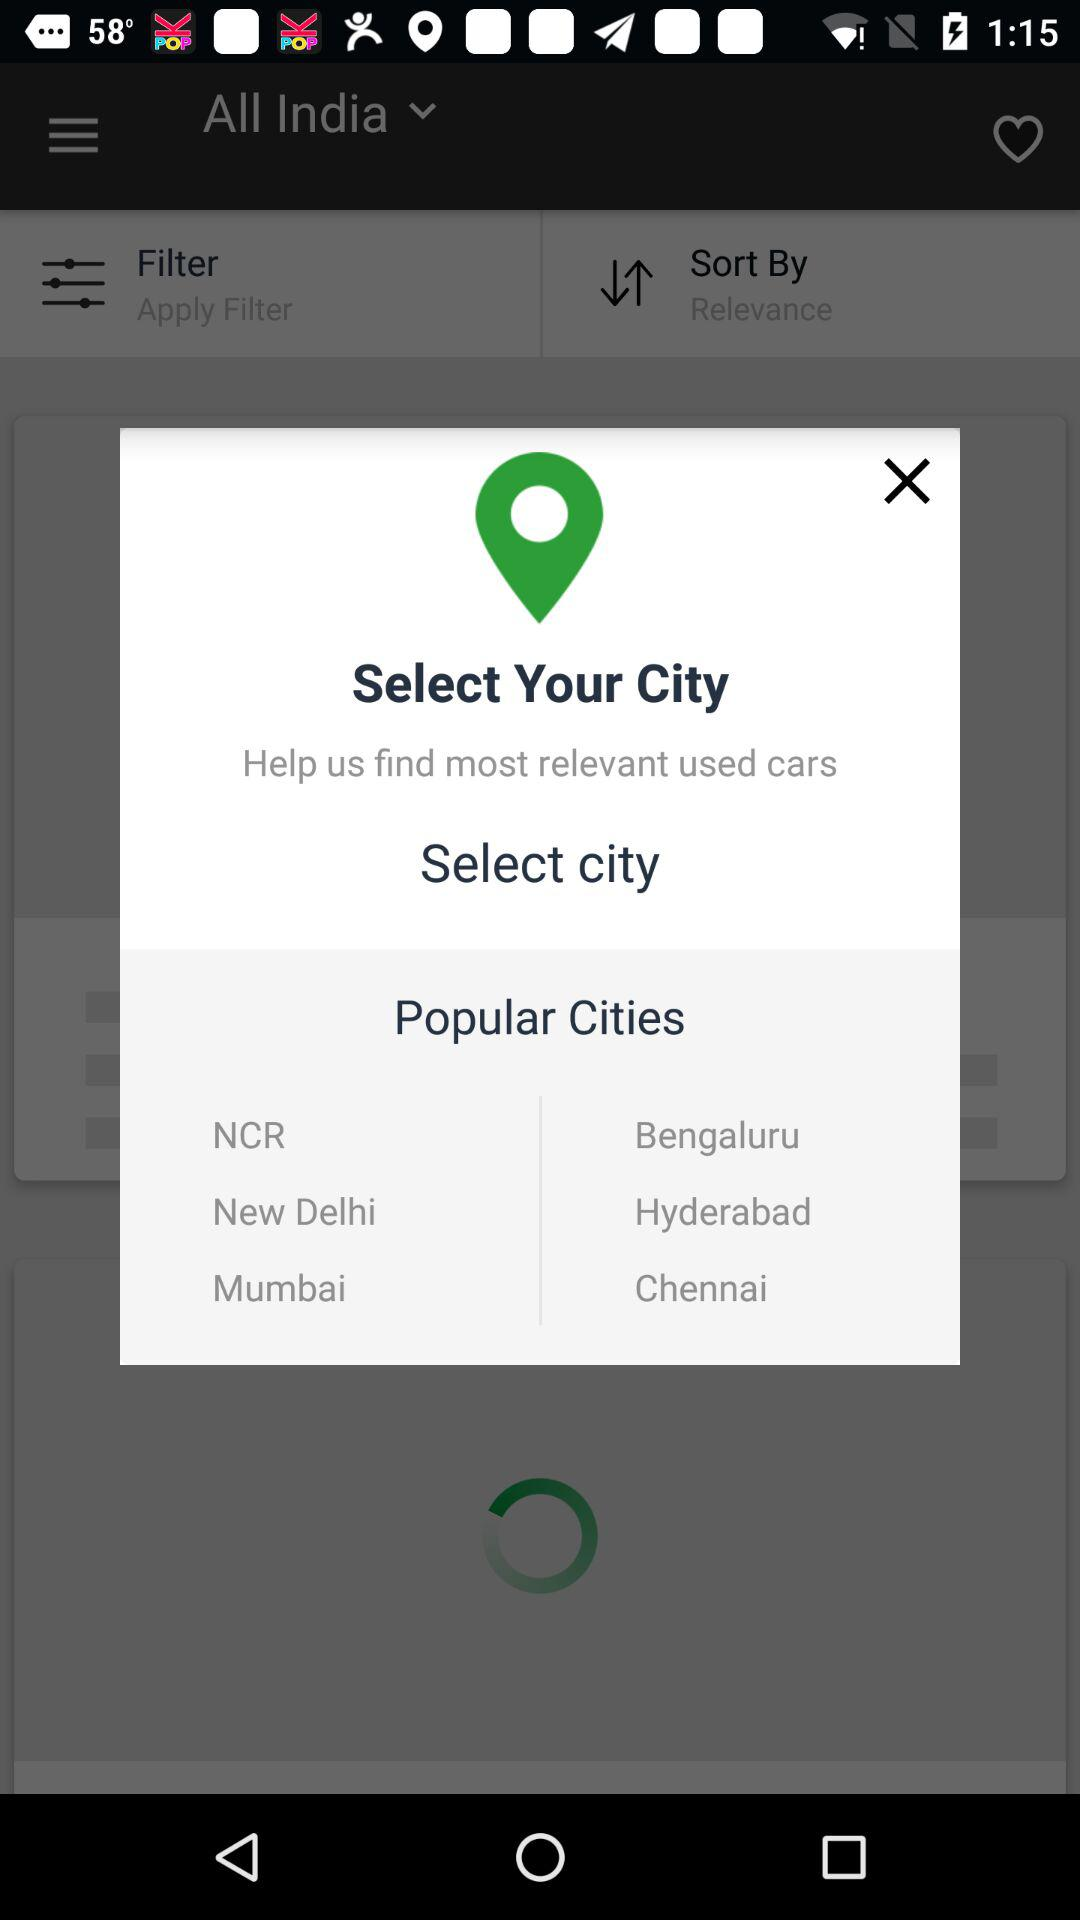What are the popular cities? The popular cities are NCR, Bengaluru, New Delhi, Hyderabad, Mumbai and Chennai. 